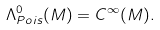Convert formula to latex. <formula><loc_0><loc_0><loc_500><loc_500>\Lambda _ { P o i s } ^ { 0 } ( M ) = C ^ { \infty } ( M ) .</formula> 